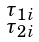Convert formula to latex. <formula><loc_0><loc_0><loc_500><loc_500>\begin{smallmatrix} \tau _ { 1 i } \\ \tau _ { 2 i } \end{smallmatrix}</formula> 